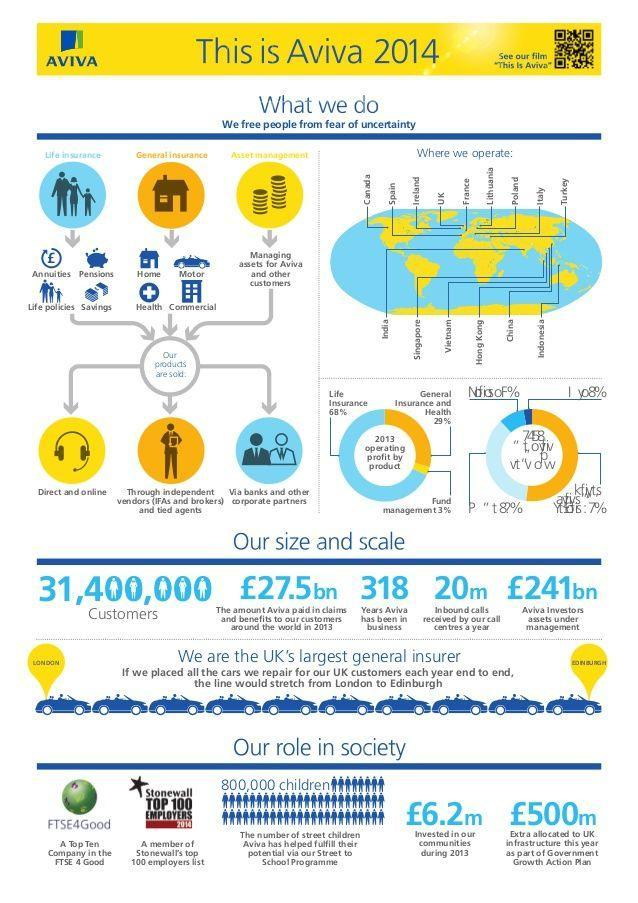How many ways of sale are available for Aviva
Answer the question with a short phrase. 3 How many customers does Aviva have 31,400,000 How many centuries has Aviva been in business 3 What is the operating profit from General Insurance and Health 29% What is the operating profit from Life insurance 68% how much was the amount in pounds allocated as a part of Government Action Plan 500m What are the incoming call count per year 20m 